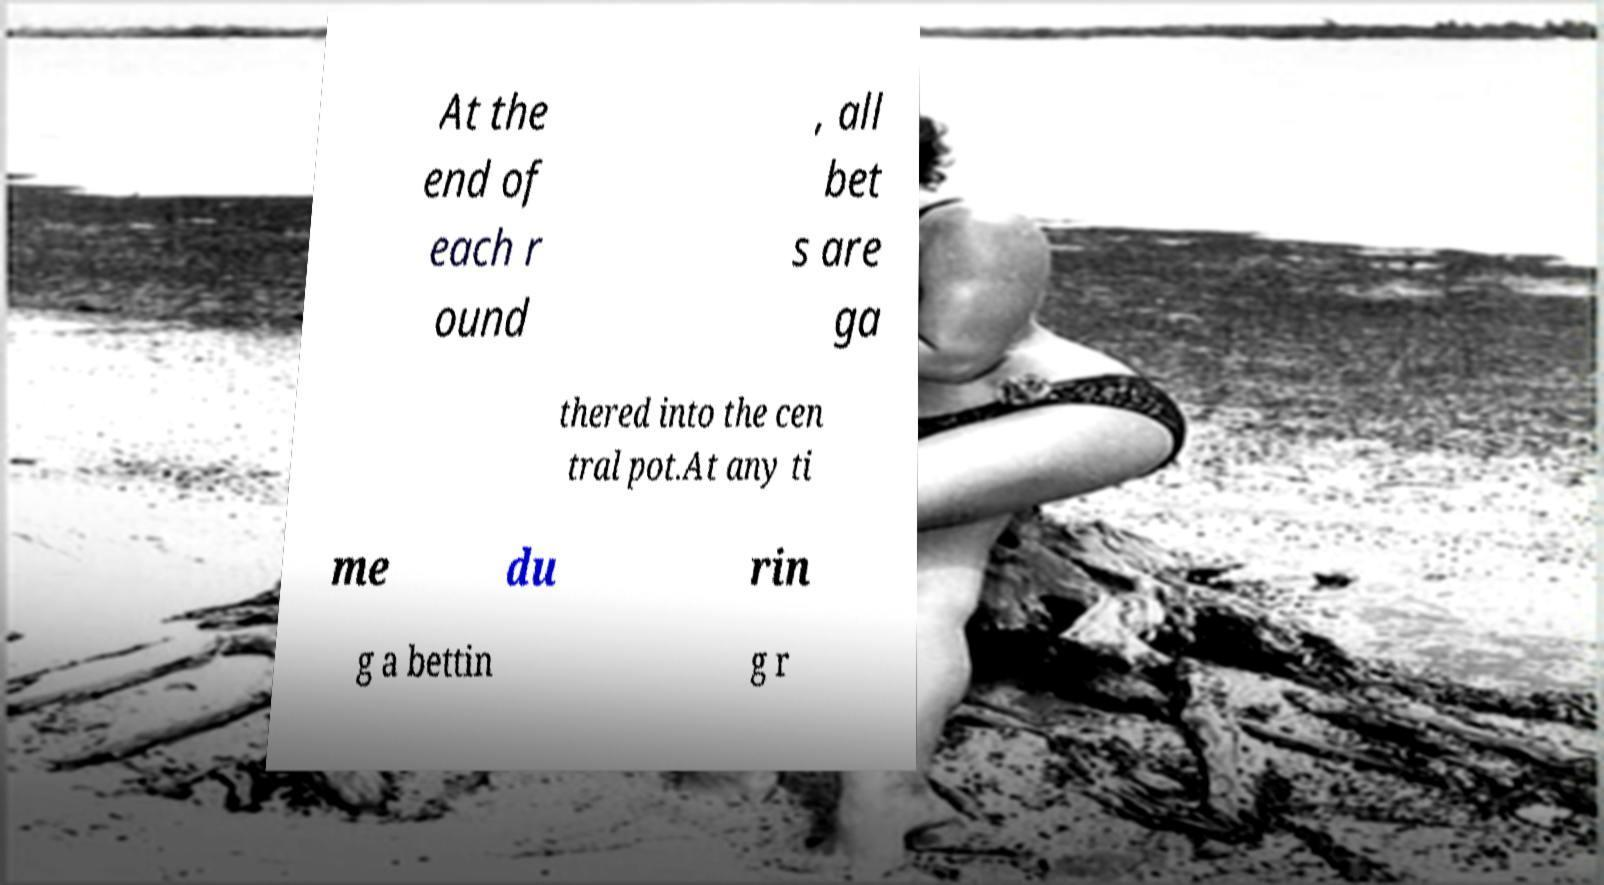I need the written content from this picture converted into text. Can you do that? At the end of each r ound , all bet s are ga thered into the cen tral pot.At any ti me du rin g a bettin g r 